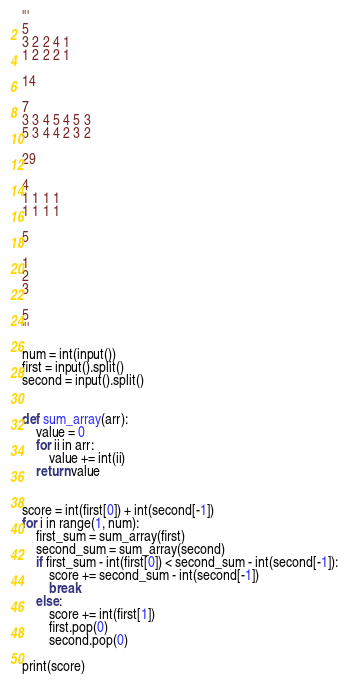<code> <loc_0><loc_0><loc_500><loc_500><_Python_>'''
5
3 2 2 4 1
1 2 2 2 1

14

7
3 3 4 5 4 5 3
5 3 4 4 2 3 2

29

4
1 1 1 1
1 1 1 1

5

1
2
3

5
'''

num = int(input())
first = input().split()
second = input().split()


def sum_array(arr):
    value = 0
    for ii in arr:
        value += int(ii)
    return value


score = int(first[0]) + int(second[-1])
for i in range(1, num):
    first_sum = sum_array(first)
    second_sum = sum_array(second)
    if first_sum - int(first[0]) < second_sum - int(second[-1]):
        score += second_sum - int(second[-1])
        break
    else:
        score += int(first[1])
        first.pop(0)
        second.pop(0)

print(score)
</code> 